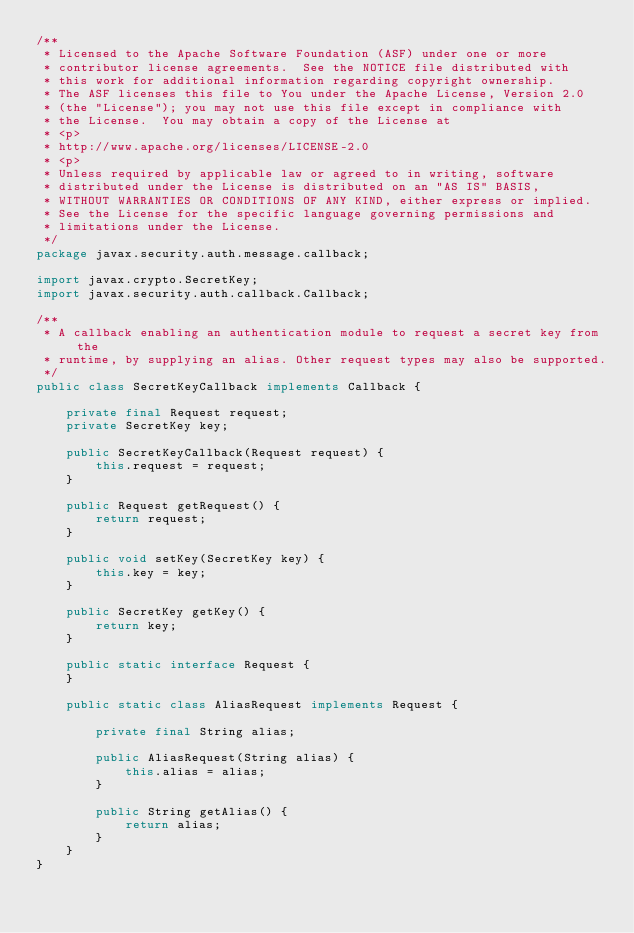Convert code to text. <code><loc_0><loc_0><loc_500><loc_500><_Java_>/**
 * Licensed to the Apache Software Foundation (ASF) under one or more
 * contributor license agreements.  See the NOTICE file distributed with
 * this work for additional information regarding copyright ownership.
 * The ASF licenses this file to You under the Apache License, Version 2.0
 * (the "License"); you may not use this file except in compliance with
 * the License.  You may obtain a copy of the License at
 * <p>
 * http://www.apache.org/licenses/LICENSE-2.0
 * <p>
 * Unless required by applicable law or agreed to in writing, software
 * distributed under the License is distributed on an "AS IS" BASIS,
 * WITHOUT WARRANTIES OR CONDITIONS OF ANY KIND, either express or implied.
 * See the License for the specific language governing permissions and
 * limitations under the License.
 */
package javax.security.auth.message.callback;

import javax.crypto.SecretKey;
import javax.security.auth.callback.Callback;

/**
 * A callback enabling an authentication module to request a secret key from the
 * runtime, by supplying an alias. Other request types may also be supported.
 */
public class SecretKeyCallback implements Callback {

    private final Request request;
    private SecretKey key;

    public SecretKeyCallback(Request request) {
        this.request = request;
    }

    public Request getRequest() {
        return request;
    }

    public void setKey(SecretKey key) {
        this.key = key;
    }

    public SecretKey getKey() {
        return key;
    }

    public static interface Request {
    }

    public static class AliasRequest implements Request {

        private final String alias;

        public AliasRequest(String alias) {
            this.alias = alias;
        }

        public String getAlias() {
            return alias;
        }
    }
}
</code> 